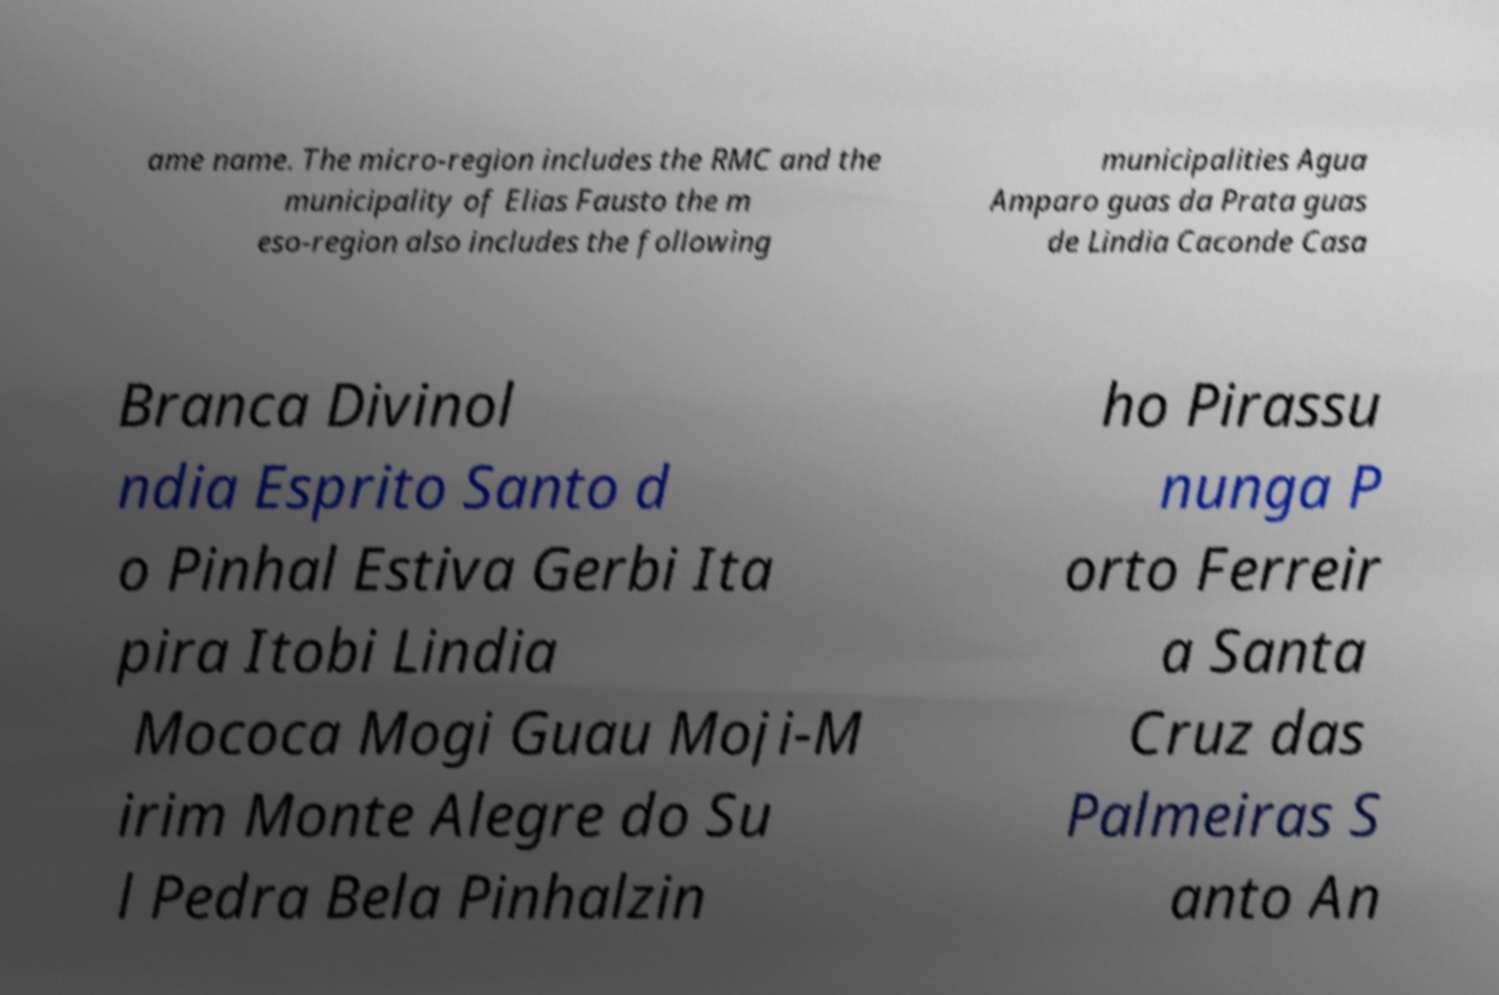Could you assist in decoding the text presented in this image and type it out clearly? ame name. The micro-region includes the RMC and the municipality of Elias Fausto the m eso-region also includes the following municipalities Agua Amparo guas da Prata guas de Lindia Caconde Casa Branca Divinol ndia Esprito Santo d o Pinhal Estiva Gerbi Ita pira Itobi Lindia Mococa Mogi Guau Moji-M irim Monte Alegre do Su l Pedra Bela Pinhalzin ho Pirassu nunga P orto Ferreir a Santa Cruz das Palmeiras S anto An 